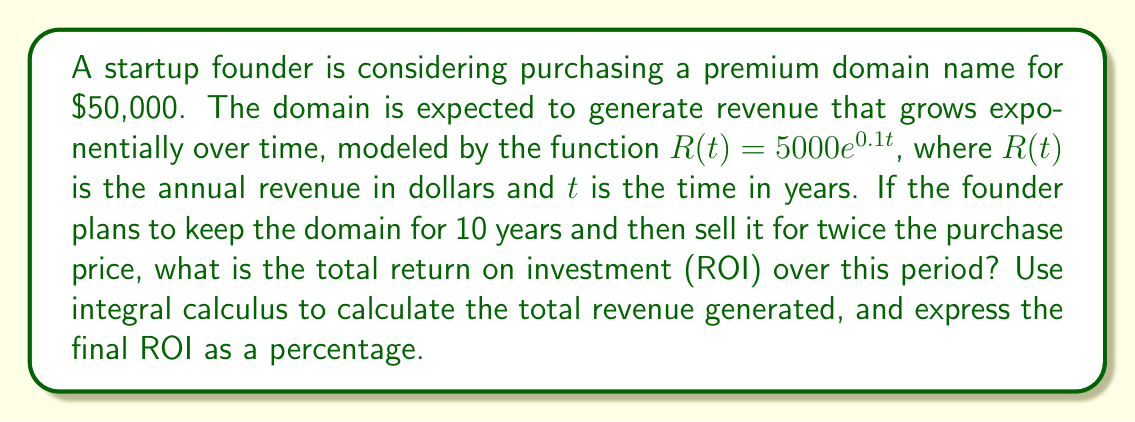Can you solve this math problem? Let's approach this problem step-by-step:

1) First, we need to calculate the total revenue generated over the 10-year period. This can be done by integrating the revenue function from 0 to 10:

   $$\text{Total Revenue} = \int_0^{10} 5000e^{0.1t} dt$$

2) To solve this integral:
   $$\int_0^{10} 5000e^{0.1t} dt = 5000 \cdot \frac{1}{0.1} \cdot [e^{0.1t}]_0^{10}$$
   $$= 50000 \cdot [e^1 - 1] = 50000 \cdot (e - 1) \approx 86,065.73$$

3) The total revenue over 10 years is approximately $86,065.73.

4) Now, let's calculate the total return:
   - Initial investment: $50,000
   - Revenue over 10 years: $86,065.73
   - Sale price after 10 years: $100,000 (twice the purchase price)

   Total return = Revenue + Sale price - Initial investment
                = $86,065.73 + $100,000 - $50,000 = $136,065.73

5) To calculate ROI as a percentage:
   $$ROI = \frac{\text{Total Return}}{\text{Initial Investment}} \times 100\%$$
   $$= \frac{136,065.73}{50,000} \times 100\% \approx 272.13\%$$
Answer: 272.13% 